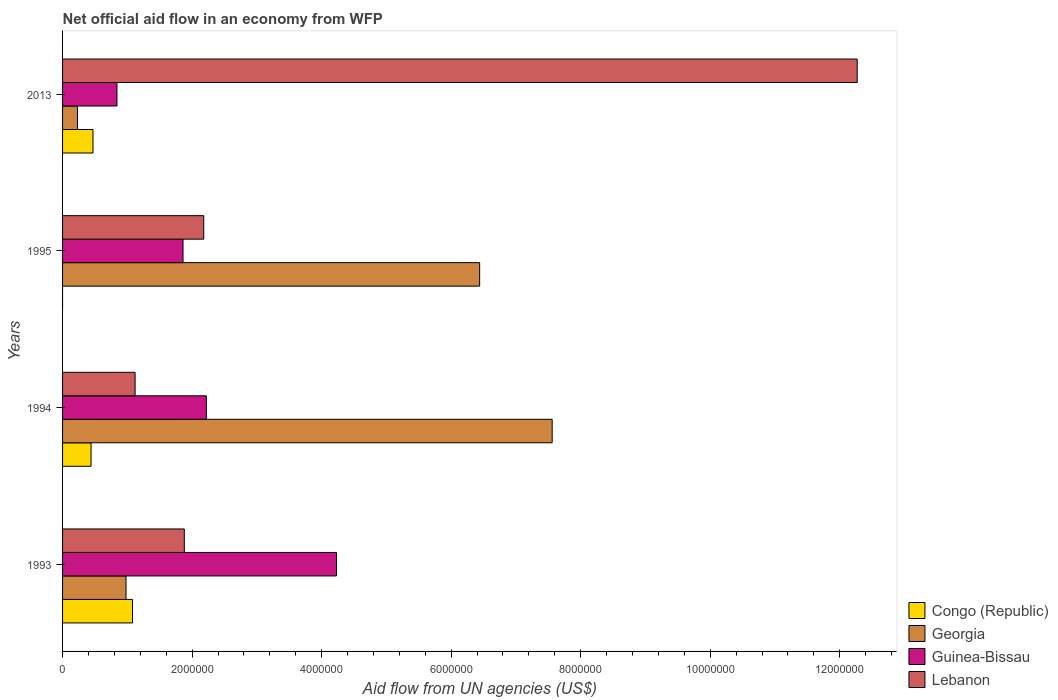Are the number of bars per tick equal to the number of legend labels?
Provide a succinct answer. No. How many bars are there on the 1st tick from the top?
Your response must be concise. 4. How many bars are there on the 3rd tick from the bottom?
Make the answer very short. 3. What is the net official aid flow in Georgia in 1995?
Provide a succinct answer. 6.44e+06. Across all years, what is the maximum net official aid flow in Lebanon?
Provide a short and direct response. 1.23e+07. Across all years, what is the minimum net official aid flow in Lebanon?
Your answer should be compact. 1.12e+06. What is the total net official aid flow in Guinea-Bissau in the graph?
Provide a short and direct response. 9.15e+06. What is the difference between the net official aid flow in Guinea-Bissau in 1993 and that in 1995?
Your response must be concise. 2.37e+06. What is the difference between the net official aid flow in Guinea-Bissau in 1994 and the net official aid flow in Georgia in 1995?
Ensure brevity in your answer.  -4.22e+06. What is the average net official aid flow in Guinea-Bissau per year?
Your response must be concise. 2.29e+06. In the year 2013, what is the difference between the net official aid flow in Congo (Republic) and net official aid flow in Lebanon?
Your answer should be compact. -1.18e+07. What is the ratio of the net official aid flow in Guinea-Bissau in 1993 to that in 1995?
Your answer should be compact. 2.27. Is the difference between the net official aid flow in Congo (Republic) in 1993 and 1994 greater than the difference between the net official aid flow in Lebanon in 1993 and 1994?
Your response must be concise. No. What is the difference between the highest and the second highest net official aid flow in Guinea-Bissau?
Offer a very short reply. 2.01e+06. What is the difference between the highest and the lowest net official aid flow in Lebanon?
Make the answer very short. 1.12e+07. In how many years, is the net official aid flow in Lebanon greater than the average net official aid flow in Lebanon taken over all years?
Ensure brevity in your answer.  1. Is the sum of the net official aid flow in Lebanon in 1993 and 1994 greater than the maximum net official aid flow in Georgia across all years?
Offer a terse response. No. Is it the case that in every year, the sum of the net official aid flow in Guinea-Bissau and net official aid flow in Congo (Republic) is greater than the sum of net official aid flow in Lebanon and net official aid flow in Georgia?
Offer a very short reply. No. How many bars are there?
Your answer should be very brief. 15. How many years are there in the graph?
Your answer should be compact. 4. Are the values on the major ticks of X-axis written in scientific E-notation?
Your answer should be compact. No. Does the graph contain grids?
Keep it short and to the point. No. How many legend labels are there?
Give a very brief answer. 4. What is the title of the graph?
Provide a short and direct response. Net official aid flow in an economy from WFP. Does "Macao" appear as one of the legend labels in the graph?
Provide a short and direct response. No. What is the label or title of the X-axis?
Provide a succinct answer. Aid flow from UN agencies (US$). What is the Aid flow from UN agencies (US$) in Congo (Republic) in 1993?
Your answer should be very brief. 1.08e+06. What is the Aid flow from UN agencies (US$) of Georgia in 1993?
Keep it short and to the point. 9.80e+05. What is the Aid flow from UN agencies (US$) in Guinea-Bissau in 1993?
Make the answer very short. 4.23e+06. What is the Aid flow from UN agencies (US$) of Lebanon in 1993?
Keep it short and to the point. 1.88e+06. What is the Aid flow from UN agencies (US$) of Congo (Republic) in 1994?
Give a very brief answer. 4.40e+05. What is the Aid flow from UN agencies (US$) of Georgia in 1994?
Your answer should be very brief. 7.56e+06. What is the Aid flow from UN agencies (US$) of Guinea-Bissau in 1994?
Offer a terse response. 2.22e+06. What is the Aid flow from UN agencies (US$) of Lebanon in 1994?
Provide a short and direct response. 1.12e+06. What is the Aid flow from UN agencies (US$) in Congo (Republic) in 1995?
Ensure brevity in your answer.  0. What is the Aid flow from UN agencies (US$) of Georgia in 1995?
Your response must be concise. 6.44e+06. What is the Aid flow from UN agencies (US$) of Guinea-Bissau in 1995?
Keep it short and to the point. 1.86e+06. What is the Aid flow from UN agencies (US$) of Lebanon in 1995?
Offer a terse response. 2.18e+06. What is the Aid flow from UN agencies (US$) in Guinea-Bissau in 2013?
Your answer should be very brief. 8.40e+05. What is the Aid flow from UN agencies (US$) in Lebanon in 2013?
Your answer should be very brief. 1.23e+07. Across all years, what is the maximum Aid flow from UN agencies (US$) in Congo (Republic)?
Provide a short and direct response. 1.08e+06. Across all years, what is the maximum Aid flow from UN agencies (US$) in Georgia?
Offer a terse response. 7.56e+06. Across all years, what is the maximum Aid flow from UN agencies (US$) of Guinea-Bissau?
Make the answer very short. 4.23e+06. Across all years, what is the maximum Aid flow from UN agencies (US$) of Lebanon?
Offer a very short reply. 1.23e+07. Across all years, what is the minimum Aid flow from UN agencies (US$) in Congo (Republic)?
Your answer should be very brief. 0. Across all years, what is the minimum Aid flow from UN agencies (US$) in Georgia?
Your answer should be compact. 2.30e+05. Across all years, what is the minimum Aid flow from UN agencies (US$) in Guinea-Bissau?
Offer a very short reply. 8.40e+05. Across all years, what is the minimum Aid flow from UN agencies (US$) of Lebanon?
Provide a short and direct response. 1.12e+06. What is the total Aid flow from UN agencies (US$) of Congo (Republic) in the graph?
Make the answer very short. 1.99e+06. What is the total Aid flow from UN agencies (US$) in Georgia in the graph?
Your response must be concise. 1.52e+07. What is the total Aid flow from UN agencies (US$) in Guinea-Bissau in the graph?
Offer a terse response. 9.15e+06. What is the total Aid flow from UN agencies (US$) in Lebanon in the graph?
Give a very brief answer. 1.74e+07. What is the difference between the Aid flow from UN agencies (US$) of Congo (Republic) in 1993 and that in 1994?
Provide a short and direct response. 6.40e+05. What is the difference between the Aid flow from UN agencies (US$) of Georgia in 1993 and that in 1994?
Your response must be concise. -6.58e+06. What is the difference between the Aid flow from UN agencies (US$) in Guinea-Bissau in 1993 and that in 1994?
Provide a succinct answer. 2.01e+06. What is the difference between the Aid flow from UN agencies (US$) in Lebanon in 1993 and that in 1994?
Give a very brief answer. 7.60e+05. What is the difference between the Aid flow from UN agencies (US$) of Georgia in 1993 and that in 1995?
Give a very brief answer. -5.46e+06. What is the difference between the Aid flow from UN agencies (US$) in Guinea-Bissau in 1993 and that in 1995?
Offer a very short reply. 2.37e+06. What is the difference between the Aid flow from UN agencies (US$) of Lebanon in 1993 and that in 1995?
Provide a succinct answer. -3.00e+05. What is the difference between the Aid flow from UN agencies (US$) of Congo (Republic) in 1993 and that in 2013?
Your answer should be very brief. 6.10e+05. What is the difference between the Aid flow from UN agencies (US$) of Georgia in 1993 and that in 2013?
Provide a succinct answer. 7.50e+05. What is the difference between the Aid flow from UN agencies (US$) of Guinea-Bissau in 1993 and that in 2013?
Your answer should be very brief. 3.39e+06. What is the difference between the Aid flow from UN agencies (US$) in Lebanon in 1993 and that in 2013?
Your answer should be very brief. -1.04e+07. What is the difference between the Aid flow from UN agencies (US$) in Georgia in 1994 and that in 1995?
Ensure brevity in your answer.  1.12e+06. What is the difference between the Aid flow from UN agencies (US$) of Guinea-Bissau in 1994 and that in 1995?
Give a very brief answer. 3.60e+05. What is the difference between the Aid flow from UN agencies (US$) of Lebanon in 1994 and that in 1995?
Provide a succinct answer. -1.06e+06. What is the difference between the Aid flow from UN agencies (US$) in Congo (Republic) in 1994 and that in 2013?
Keep it short and to the point. -3.00e+04. What is the difference between the Aid flow from UN agencies (US$) of Georgia in 1994 and that in 2013?
Provide a short and direct response. 7.33e+06. What is the difference between the Aid flow from UN agencies (US$) of Guinea-Bissau in 1994 and that in 2013?
Offer a terse response. 1.38e+06. What is the difference between the Aid flow from UN agencies (US$) in Lebanon in 1994 and that in 2013?
Provide a short and direct response. -1.12e+07. What is the difference between the Aid flow from UN agencies (US$) in Georgia in 1995 and that in 2013?
Offer a very short reply. 6.21e+06. What is the difference between the Aid flow from UN agencies (US$) of Guinea-Bissau in 1995 and that in 2013?
Offer a terse response. 1.02e+06. What is the difference between the Aid flow from UN agencies (US$) of Lebanon in 1995 and that in 2013?
Keep it short and to the point. -1.01e+07. What is the difference between the Aid flow from UN agencies (US$) of Congo (Republic) in 1993 and the Aid flow from UN agencies (US$) of Georgia in 1994?
Your answer should be compact. -6.48e+06. What is the difference between the Aid flow from UN agencies (US$) of Congo (Republic) in 1993 and the Aid flow from UN agencies (US$) of Guinea-Bissau in 1994?
Your answer should be compact. -1.14e+06. What is the difference between the Aid flow from UN agencies (US$) of Georgia in 1993 and the Aid flow from UN agencies (US$) of Guinea-Bissau in 1994?
Provide a succinct answer. -1.24e+06. What is the difference between the Aid flow from UN agencies (US$) in Guinea-Bissau in 1993 and the Aid flow from UN agencies (US$) in Lebanon in 1994?
Your response must be concise. 3.11e+06. What is the difference between the Aid flow from UN agencies (US$) in Congo (Republic) in 1993 and the Aid flow from UN agencies (US$) in Georgia in 1995?
Keep it short and to the point. -5.36e+06. What is the difference between the Aid flow from UN agencies (US$) of Congo (Republic) in 1993 and the Aid flow from UN agencies (US$) of Guinea-Bissau in 1995?
Your response must be concise. -7.80e+05. What is the difference between the Aid flow from UN agencies (US$) in Congo (Republic) in 1993 and the Aid flow from UN agencies (US$) in Lebanon in 1995?
Offer a very short reply. -1.10e+06. What is the difference between the Aid flow from UN agencies (US$) of Georgia in 1993 and the Aid flow from UN agencies (US$) of Guinea-Bissau in 1995?
Your response must be concise. -8.80e+05. What is the difference between the Aid flow from UN agencies (US$) of Georgia in 1993 and the Aid flow from UN agencies (US$) of Lebanon in 1995?
Provide a succinct answer. -1.20e+06. What is the difference between the Aid flow from UN agencies (US$) in Guinea-Bissau in 1993 and the Aid flow from UN agencies (US$) in Lebanon in 1995?
Offer a very short reply. 2.05e+06. What is the difference between the Aid flow from UN agencies (US$) in Congo (Republic) in 1993 and the Aid flow from UN agencies (US$) in Georgia in 2013?
Make the answer very short. 8.50e+05. What is the difference between the Aid flow from UN agencies (US$) in Congo (Republic) in 1993 and the Aid flow from UN agencies (US$) in Guinea-Bissau in 2013?
Give a very brief answer. 2.40e+05. What is the difference between the Aid flow from UN agencies (US$) of Congo (Republic) in 1993 and the Aid flow from UN agencies (US$) of Lebanon in 2013?
Your response must be concise. -1.12e+07. What is the difference between the Aid flow from UN agencies (US$) in Georgia in 1993 and the Aid flow from UN agencies (US$) in Guinea-Bissau in 2013?
Your answer should be compact. 1.40e+05. What is the difference between the Aid flow from UN agencies (US$) of Georgia in 1993 and the Aid flow from UN agencies (US$) of Lebanon in 2013?
Your answer should be very brief. -1.13e+07. What is the difference between the Aid flow from UN agencies (US$) in Guinea-Bissau in 1993 and the Aid flow from UN agencies (US$) in Lebanon in 2013?
Your answer should be compact. -8.04e+06. What is the difference between the Aid flow from UN agencies (US$) of Congo (Republic) in 1994 and the Aid flow from UN agencies (US$) of Georgia in 1995?
Keep it short and to the point. -6.00e+06. What is the difference between the Aid flow from UN agencies (US$) of Congo (Republic) in 1994 and the Aid flow from UN agencies (US$) of Guinea-Bissau in 1995?
Offer a terse response. -1.42e+06. What is the difference between the Aid flow from UN agencies (US$) in Congo (Republic) in 1994 and the Aid flow from UN agencies (US$) in Lebanon in 1995?
Ensure brevity in your answer.  -1.74e+06. What is the difference between the Aid flow from UN agencies (US$) in Georgia in 1994 and the Aid flow from UN agencies (US$) in Guinea-Bissau in 1995?
Make the answer very short. 5.70e+06. What is the difference between the Aid flow from UN agencies (US$) in Georgia in 1994 and the Aid flow from UN agencies (US$) in Lebanon in 1995?
Keep it short and to the point. 5.38e+06. What is the difference between the Aid flow from UN agencies (US$) in Congo (Republic) in 1994 and the Aid flow from UN agencies (US$) in Georgia in 2013?
Give a very brief answer. 2.10e+05. What is the difference between the Aid flow from UN agencies (US$) in Congo (Republic) in 1994 and the Aid flow from UN agencies (US$) in Guinea-Bissau in 2013?
Your response must be concise. -4.00e+05. What is the difference between the Aid flow from UN agencies (US$) of Congo (Republic) in 1994 and the Aid flow from UN agencies (US$) of Lebanon in 2013?
Offer a very short reply. -1.18e+07. What is the difference between the Aid flow from UN agencies (US$) in Georgia in 1994 and the Aid flow from UN agencies (US$) in Guinea-Bissau in 2013?
Make the answer very short. 6.72e+06. What is the difference between the Aid flow from UN agencies (US$) in Georgia in 1994 and the Aid flow from UN agencies (US$) in Lebanon in 2013?
Offer a terse response. -4.71e+06. What is the difference between the Aid flow from UN agencies (US$) in Guinea-Bissau in 1994 and the Aid flow from UN agencies (US$) in Lebanon in 2013?
Offer a terse response. -1.00e+07. What is the difference between the Aid flow from UN agencies (US$) of Georgia in 1995 and the Aid flow from UN agencies (US$) of Guinea-Bissau in 2013?
Make the answer very short. 5.60e+06. What is the difference between the Aid flow from UN agencies (US$) of Georgia in 1995 and the Aid flow from UN agencies (US$) of Lebanon in 2013?
Make the answer very short. -5.83e+06. What is the difference between the Aid flow from UN agencies (US$) of Guinea-Bissau in 1995 and the Aid flow from UN agencies (US$) of Lebanon in 2013?
Ensure brevity in your answer.  -1.04e+07. What is the average Aid flow from UN agencies (US$) of Congo (Republic) per year?
Offer a very short reply. 4.98e+05. What is the average Aid flow from UN agencies (US$) in Georgia per year?
Your answer should be very brief. 3.80e+06. What is the average Aid flow from UN agencies (US$) in Guinea-Bissau per year?
Ensure brevity in your answer.  2.29e+06. What is the average Aid flow from UN agencies (US$) of Lebanon per year?
Provide a succinct answer. 4.36e+06. In the year 1993, what is the difference between the Aid flow from UN agencies (US$) in Congo (Republic) and Aid flow from UN agencies (US$) in Georgia?
Provide a short and direct response. 1.00e+05. In the year 1993, what is the difference between the Aid flow from UN agencies (US$) of Congo (Republic) and Aid flow from UN agencies (US$) of Guinea-Bissau?
Offer a very short reply. -3.15e+06. In the year 1993, what is the difference between the Aid flow from UN agencies (US$) of Congo (Republic) and Aid flow from UN agencies (US$) of Lebanon?
Make the answer very short. -8.00e+05. In the year 1993, what is the difference between the Aid flow from UN agencies (US$) in Georgia and Aid flow from UN agencies (US$) in Guinea-Bissau?
Provide a short and direct response. -3.25e+06. In the year 1993, what is the difference between the Aid flow from UN agencies (US$) in Georgia and Aid flow from UN agencies (US$) in Lebanon?
Offer a terse response. -9.00e+05. In the year 1993, what is the difference between the Aid flow from UN agencies (US$) in Guinea-Bissau and Aid flow from UN agencies (US$) in Lebanon?
Ensure brevity in your answer.  2.35e+06. In the year 1994, what is the difference between the Aid flow from UN agencies (US$) in Congo (Republic) and Aid flow from UN agencies (US$) in Georgia?
Make the answer very short. -7.12e+06. In the year 1994, what is the difference between the Aid flow from UN agencies (US$) in Congo (Republic) and Aid flow from UN agencies (US$) in Guinea-Bissau?
Your answer should be compact. -1.78e+06. In the year 1994, what is the difference between the Aid flow from UN agencies (US$) in Congo (Republic) and Aid flow from UN agencies (US$) in Lebanon?
Your answer should be very brief. -6.80e+05. In the year 1994, what is the difference between the Aid flow from UN agencies (US$) of Georgia and Aid flow from UN agencies (US$) of Guinea-Bissau?
Give a very brief answer. 5.34e+06. In the year 1994, what is the difference between the Aid flow from UN agencies (US$) of Georgia and Aid flow from UN agencies (US$) of Lebanon?
Make the answer very short. 6.44e+06. In the year 1994, what is the difference between the Aid flow from UN agencies (US$) of Guinea-Bissau and Aid flow from UN agencies (US$) of Lebanon?
Ensure brevity in your answer.  1.10e+06. In the year 1995, what is the difference between the Aid flow from UN agencies (US$) of Georgia and Aid flow from UN agencies (US$) of Guinea-Bissau?
Keep it short and to the point. 4.58e+06. In the year 1995, what is the difference between the Aid flow from UN agencies (US$) in Georgia and Aid flow from UN agencies (US$) in Lebanon?
Your response must be concise. 4.26e+06. In the year 1995, what is the difference between the Aid flow from UN agencies (US$) in Guinea-Bissau and Aid flow from UN agencies (US$) in Lebanon?
Offer a very short reply. -3.20e+05. In the year 2013, what is the difference between the Aid flow from UN agencies (US$) of Congo (Republic) and Aid flow from UN agencies (US$) of Guinea-Bissau?
Offer a very short reply. -3.70e+05. In the year 2013, what is the difference between the Aid flow from UN agencies (US$) in Congo (Republic) and Aid flow from UN agencies (US$) in Lebanon?
Offer a very short reply. -1.18e+07. In the year 2013, what is the difference between the Aid flow from UN agencies (US$) in Georgia and Aid flow from UN agencies (US$) in Guinea-Bissau?
Ensure brevity in your answer.  -6.10e+05. In the year 2013, what is the difference between the Aid flow from UN agencies (US$) in Georgia and Aid flow from UN agencies (US$) in Lebanon?
Offer a terse response. -1.20e+07. In the year 2013, what is the difference between the Aid flow from UN agencies (US$) of Guinea-Bissau and Aid flow from UN agencies (US$) of Lebanon?
Provide a succinct answer. -1.14e+07. What is the ratio of the Aid flow from UN agencies (US$) of Congo (Republic) in 1993 to that in 1994?
Provide a succinct answer. 2.45. What is the ratio of the Aid flow from UN agencies (US$) of Georgia in 1993 to that in 1994?
Your response must be concise. 0.13. What is the ratio of the Aid flow from UN agencies (US$) of Guinea-Bissau in 1993 to that in 1994?
Provide a succinct answer. 1.91. What is the ratio of the Aid flow from UN agencies (US$) in Lebanon in 1993 to that in 1994?
Ensure brevity in your answer.  1.68. What is the ratio of the Aid flow from UN agencies (US$) in Georgia in 1993 to that in 1995?
Give a very brief answer. 0.15. What is the ratio of the Aid flow from UN agencies (US$) in Guinea-Bissau in 1993 to that in 1995?
Provide a succinct answer. 2.27. What is the ratio of the Aid flow from UN agencies (US$) in Lebanon in 1993 to that in 1995?
Give a very brief answer. 0.86. What is the ratio of the Aid flow from UN agencies (US$) of Congo (Republic) in 1993 to that in 2013?
Your answer should be compact. 2.3. What is the ratio of the Aid flow from UN agencies (US$) in Georgia in 1993 to that in 2013?
Provide a succinct answer. 4.26. What is the ratio of the Aid flow from UN agencies (US$) of Guinea-Bissau in 1993 to that in 2013?
Offer a terse response. 5.04. What is the ratio of the Aid flow from UN agencies (US$) in Lebanon in 1993 to that in 2013?
Make the answer very short. 0.15. What is the ratio of the Aid flow from UN agencies (US$) of Georgia in 1994 to that in 1995?
Make the answer very short. 1.17. What is the ratio of the Aid flow from UN agencies (US$) in Guinea-Bissau in 1994 to that in 1995?
Offer a terse response. 1.19. What is the ratio of the Aid flow from UN agencies (US$) of Lebanon in 1994 to that in 1995?
Offer a very short reply. 0.51. What is the ratio of the Aid flow from UN agencies (US$) of Congo (Republic) in 1994 to that in 2013?
Your answer should be compact. 0.94. What is the ratio of the Aid flow from UN agencies (US$) of Georgia in 1994 to that in 2013?
Provide a succinct answer. 32.87. What is the ratio of the Aid flow from UN agencies (US$) of Guinea-Bissau in 1994 to that in 2013?
Ensure brevity in your answer.  2.64. What is the ratio of the Aid flow from UN agencies (US$) in Lebanon in 1994 to that in 2013?
Provide a short and direct response. 0.09. What is the ratio of the Aid flow from UN agencies (US$) of Georgia in 1995 to that in 2013?
Your answer should be compact. 28. What is the ratio of the Aid flow from UN agencies (US$) of Guinea-Bissau in 1995 to that in 2013?
Make the answer very short. 2.21. What is the ratio of the Aid flow from UN agencies (US$) in Lebanon in 1995 to that in 2013?
Give a very brief answer. 0.18. What is the difference between the highest and the second highest Aid flow from UN agencies (US$) of Congo (Republic)?
Your response must be concise. 6.10e+05. What is the difference between the highest and the second highest Aid flow from UN agencies (US$) of Georgia?
Ensure brevity in your answer.  1.12e+06. What is the difference between the highest and the second highest Aid flow from UN agencies (US$) of Guinea-Bissau?
Make the answer very short. 2.01e+06. What is the difference between the highest and the second highest Aid flow from UN agencies (US$) of Lebanon?
Your answer should be very brief. 1.01e+07. What is the difference between the highest and the lowest Aid flow from UN agencies (US$) of Congo (Republic)?
Offer a very short reply. 1.08e+06. What is the difference between the highest and the lowest Aid flow from UN agencies (US$) in Georgia?
Make the answer very short. 7.33e+06. What is the difference between the highest and the lowest Aid flow from UN agencies (US$) of Guinea-Bissau?
Ensure brevity in your answer.  3.39e+06. What is the difference between the highest and the lowest Aid flow from UN agencies (US$) in Lebanon?
Give a very brief answer. 1.12e+07. 